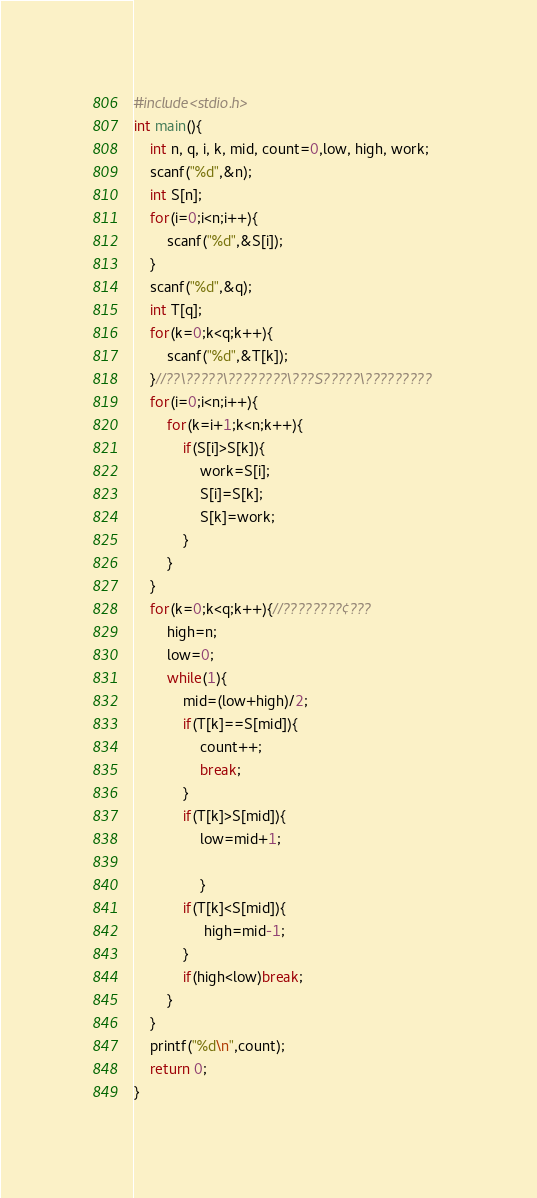Convert code to text. <code><loc_0><loc_0><loc_500><loc_500><_C_>#include<stdio.h>
int main(){
	int n, q, i, k, mid, count=0,low, high, work;
	scanf("%d",&n);
	int S[n];
	for(i=0;i<n;i++){
		scanf("%d",&S[i]);
	}
	scanf("%d",&q);
	int T[q];
	for(k=0;k<q;k++){
		scanf("%d",&T[k]);
	}//??\?????\????????\???S?????\?????????
	for(i=0;i<n;i++){
		for(k=i+1;k<n;k++){
			if(S[i]>S[k]){
				work=S[i];
				S[i]=S[k];
				S[k]=work;
			}
		}
	}
	for(k=0;k<q;k++){//????????¢???
		high=n;
		low=0;
		while(1){
			mid=(low+high)/2;
			if(T[k]==S[mid]){
				count++;
				break;
			}
			if(T[k]>S[mid]){
				low=mid+1;
				
				}
			if(T[k]<S[mid]){
				 high=mid-1;
			}	
			if(high<low)break;
		}
	}
	printf("%d\n",count);
	return 0;
}</code> 